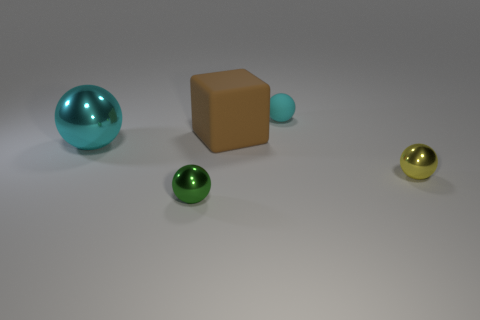What is the largest object in the scene? The largest object in the scene appears to be the teal sphere. Its size is more prominent in comparison to the other objects displayed. 